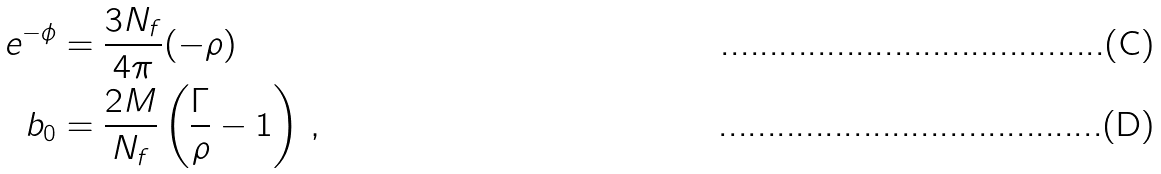Convert formula to latex. <formula><loc_0><loc_0><loc_500><loc_500>e ^ { - \phi } & = \frac { 3 N _ { f } } { 4 \pi } ( - \rho ) \\ b _ { 0 } & = \frac { 2 M } { N _ { f } } \left ( \frac { \Gamma } { \rho } - 1 \right ) \, ,</formula> 